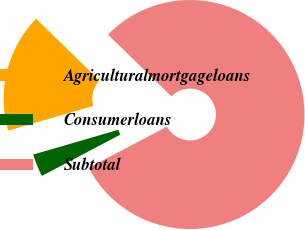Convert chart. <chart><loc_0><loc_0><loc_500><loc_500><pie_chart><fcel>Agriculturalmortgageloans<fcel>Consumerloans<fcel>Subtotal<nl><fcel>16.8%<fcel>3.2%<fcel>80.0%<nl></chart> 